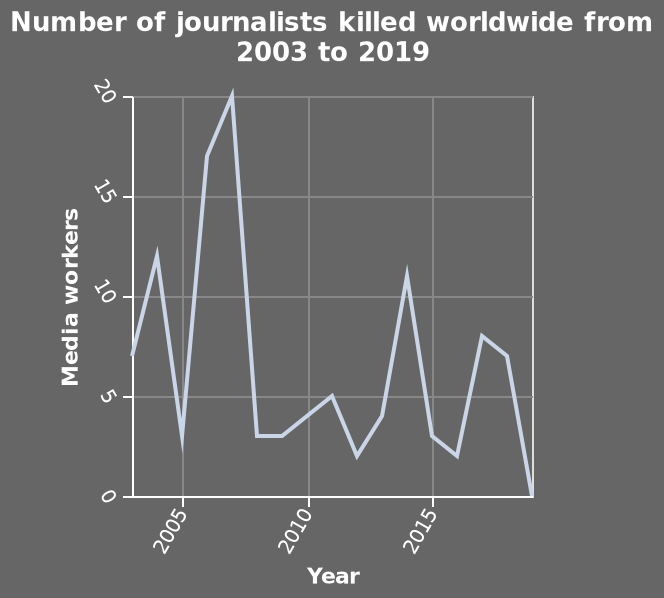<image>
What was the number of journalists killed during the peak between 2005-2010? The description does not provide information about the specific number of journalists killed during the peak between 2005-2010. What does the x-axis measure and what is its scale?  The x-axis measures the Year and is scaled from 2005 to 2015 using a linear scale. What is the time period represented in the line graph?  The line graph represents the time period from 2003 to 2019. please summary the statistics and relations of the chart The peak amount of journalists killed occured between 2005-2010. 2019 saw a low for journalists killed that hadn't been witnessed for at least 16 years. The amount of journalists killed remained the same from 2008-2009. 